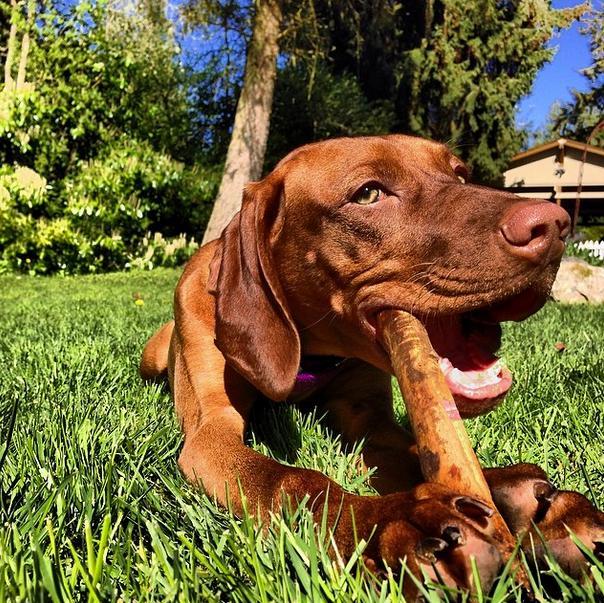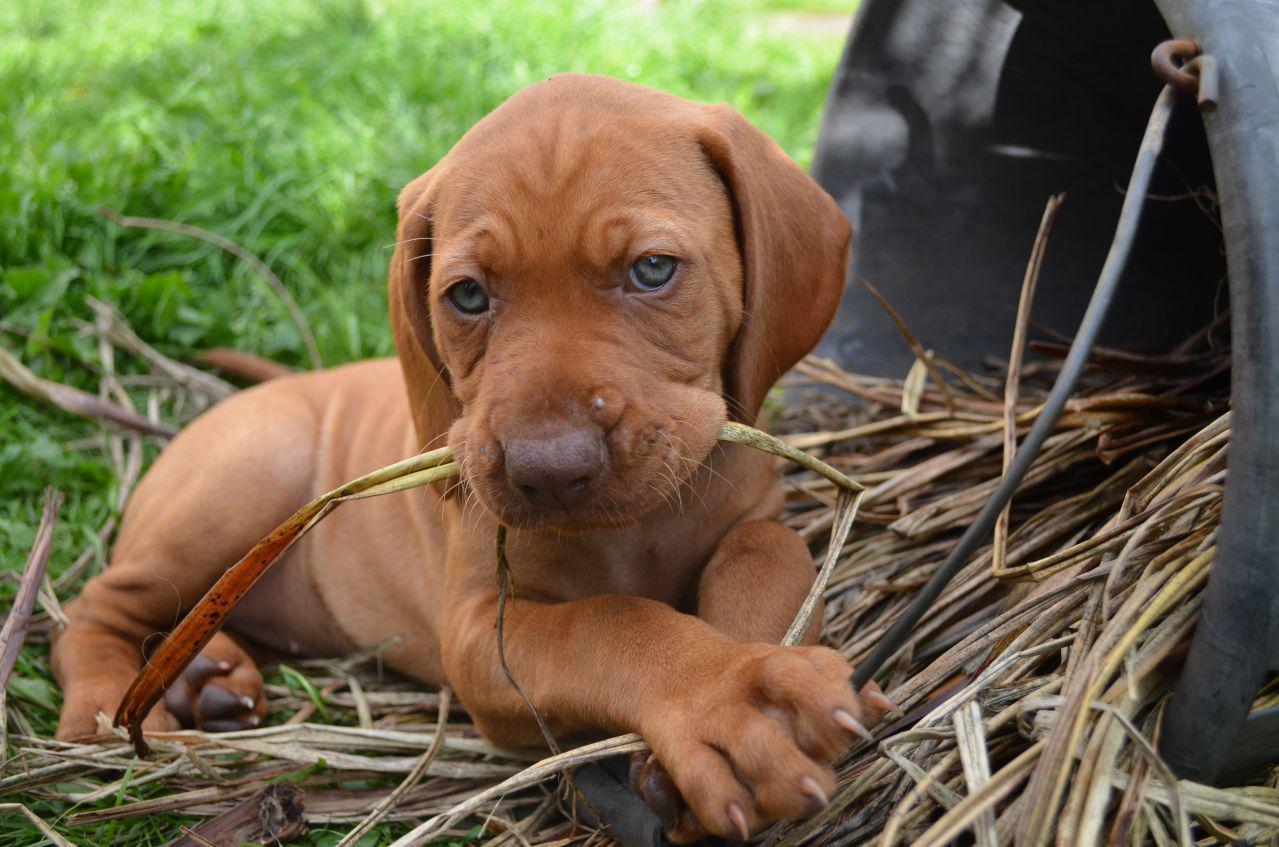The first image is the image on the left, the second image is the image on the right. Evaluate the accuracy of this statement regarding the images: "At least three dogs are visible.". Is it true? Answer yes or no. No. The first image is the image on the left, the second image is the image on the right. Considering the images on both sides, is "At least two dogs with upright heads and shoulders are near a pair of legs in blue jeans." valid? Answer yes or no. No. 